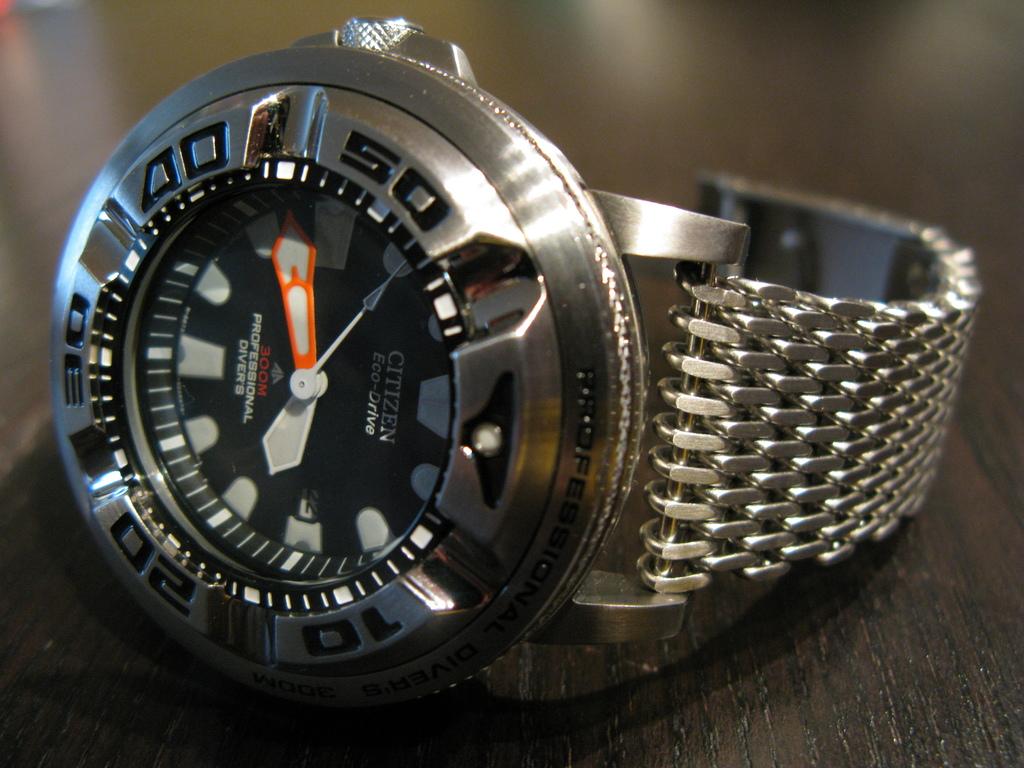What's the brand of watch?
Offer a terse response. Citizen. Is this a divers watch?
Your response must be concise. Yes. 